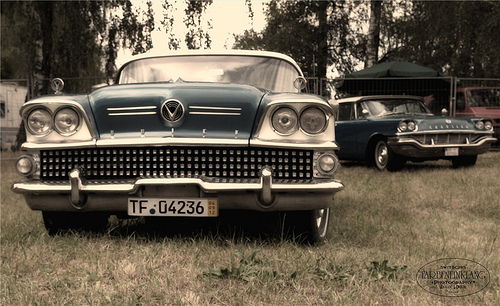<image>
Is the car to the left of the grass? No. The car is not to the left of the grass. From this viewpoint, they have a different horizontal relationship. Is the car in the ground? No. The car is not contained within the ground. These objects have a different spatial relationship. 